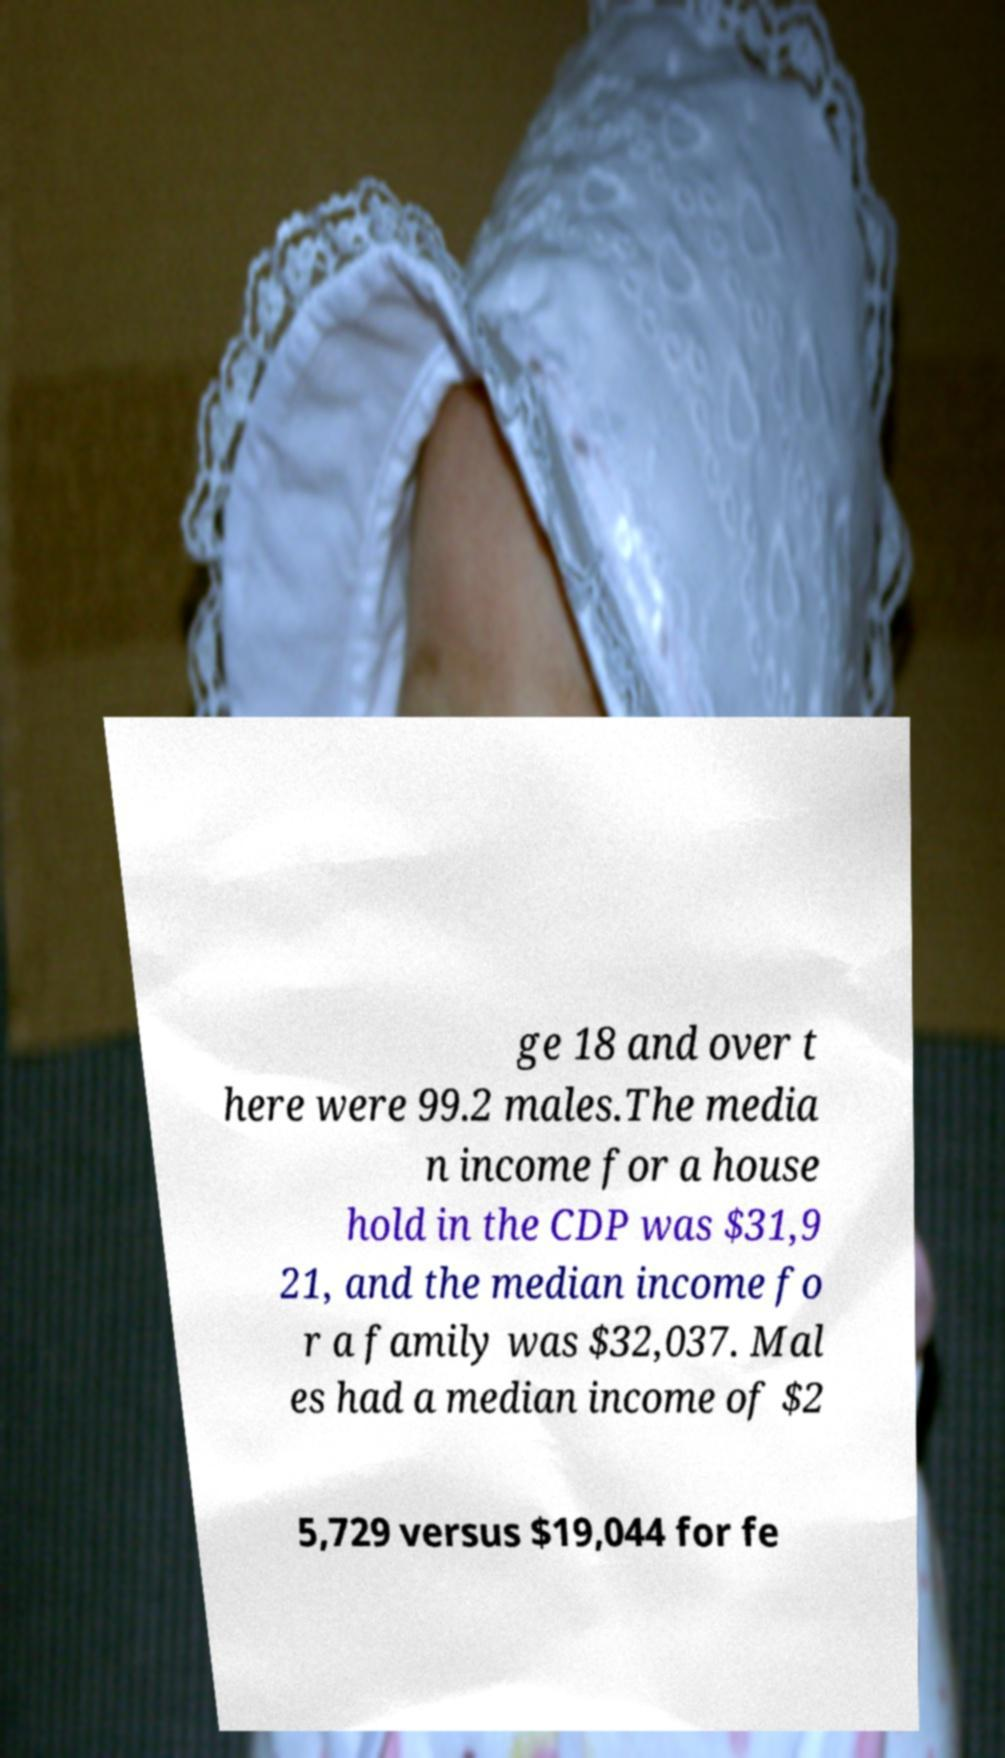Can you accurately transcribe the text from the provided image for me? ge 18 and over t here were 99.2 males.The media n income for a house hold in the CDP was $31,9 21, and the median income fo r a family was $32,037. Mal es had a median income of $2 5,729 versus $19,044 for fe 